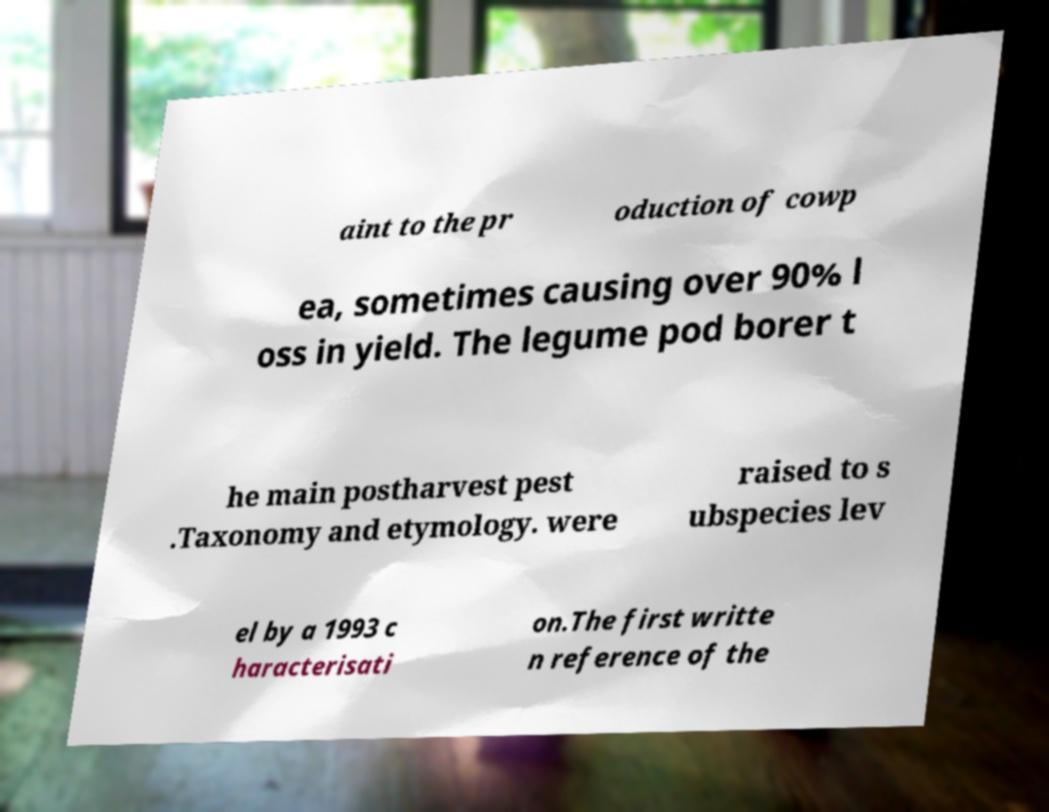Please read and relay the text visible in this image. What does it say? aint to the pr oduction of cowp ea, sometimes causing over 90% l oss in yield. The legume pod borer t he main postharvest pest .Taxonomy and etymology. were raised to s ubspecies lev el by a 1993 c haracterisati on.The first writte n reference of the 